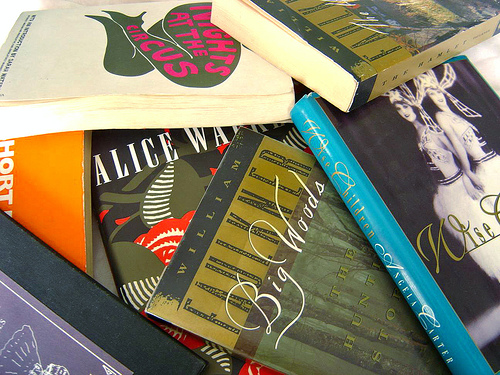<image>
Is there a book on the book? Yes. Looking at the image, I can see the book is positioned on top of the book, with the book providing support. 